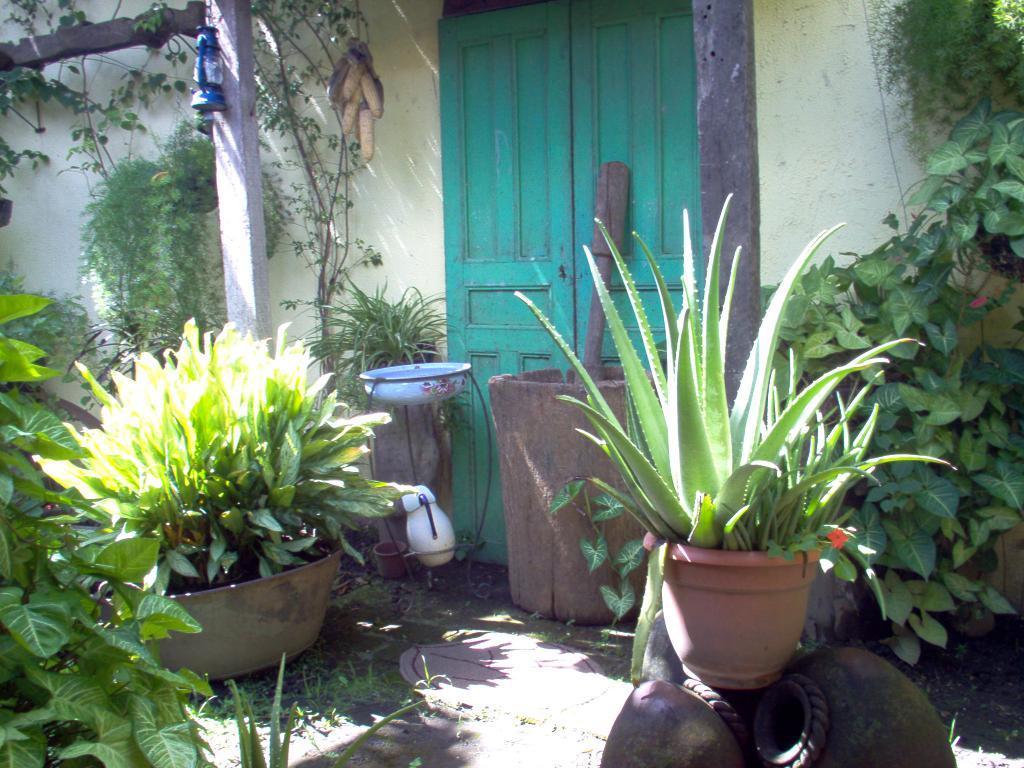Please provide a concise description of this image. This image is taken outdoors. In the background there is a wall and there is a door. There is a pole and there is a lamp. In the middle of the image there are many plants in the pots and there are few creepers. At the bottom of the image there is a ground with grass on it and there are two pots. 